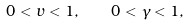Convert formula to latex. <formula><loc_0><loc_0><loc_500><loc_500>0 < v < 1 , \quad 0 < \gamma < 1 ,</formula> 